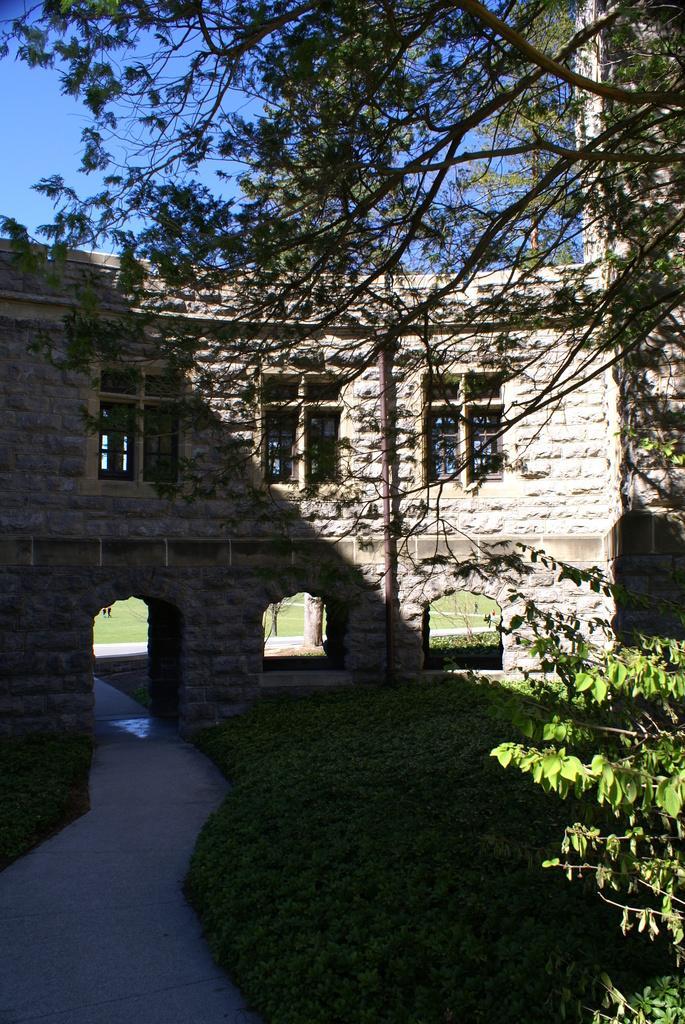Please provide a concise description of this image. In the center of the image we can see the sky, branches with leaves, grass, plants, one building, windows and pillars with arches. 